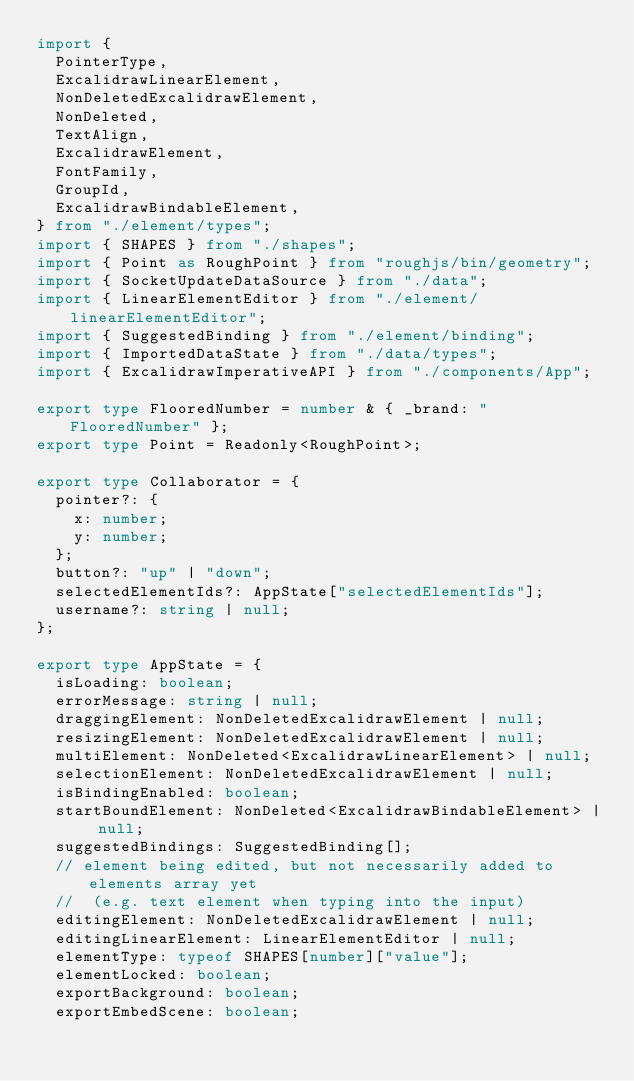Convert code to text. <code><loc_0><loc_0><loc_500><loc_500><_TypeScript_>import {
  PointerType,
  ExcalidrawLinearElement,
  NonDeletedExcalidrawElement,
  NonDeleted,
  TextAlign,
  ExcalidrawElement,
  FontFamily,
  GroupId,
  ExcalidrawBindableElement,
} from "./element/types";
import { SHAPES } from "./shapes";
import { Point as RoughPoint } from "roughjs/bin/geometry";
import { SocketUpdateDataSource } from "./data";
import { LinearElementEditor } from "./element/linearElementEditor";
import { SuggestedBinding } from "./element/binding";
import { ImportedDataState } from "./data/types";
import { ExcalidrawImperativeAPI } from "./components/App";

export type FlooredNumber = number & { _brand: "FlooredNumber" };
export type Point = Readonly<RoughPoint>;

export type Collaborator = {
  pointer?: {
    x: number;
    y: number;
  };
  button?: "up" | "down";
  selectedElementIds?: AppState["selectedElementIds"];
  username?: string | null;
};

export type AppState = {
  isLoading: boolean;
  errorMessage: string | null;
  draggingElement: NonDeletedExcalidrawElement | null;
  resizingElement: NonDeletedExcalidrawElement | null;
  multiElement: NonDeleted<ExcalidrawLinearElement> | null;
  selectionElement: NonDeletedExcalidrawElement | null;
  isBindingEnabled: boolean;
  startBoundElement: NonDeleted<ExcalidrawBindableElement> | null;
  suggestedBindings: SuggestedBinding[];
  // element being edited, but not necessarily added to elements array yet
  //  (e.g. text element when typing into the input)
  editingElement: NonDeletedExcalidrawElement | null;
  editingLinearElement: LinearElementEditor | null;
  elementType: typeof SHAPES[number]["value"];
  elementLocked: boolean;
  exportBackground: boolean;
  exportEmbedScene: boolean;</code> 